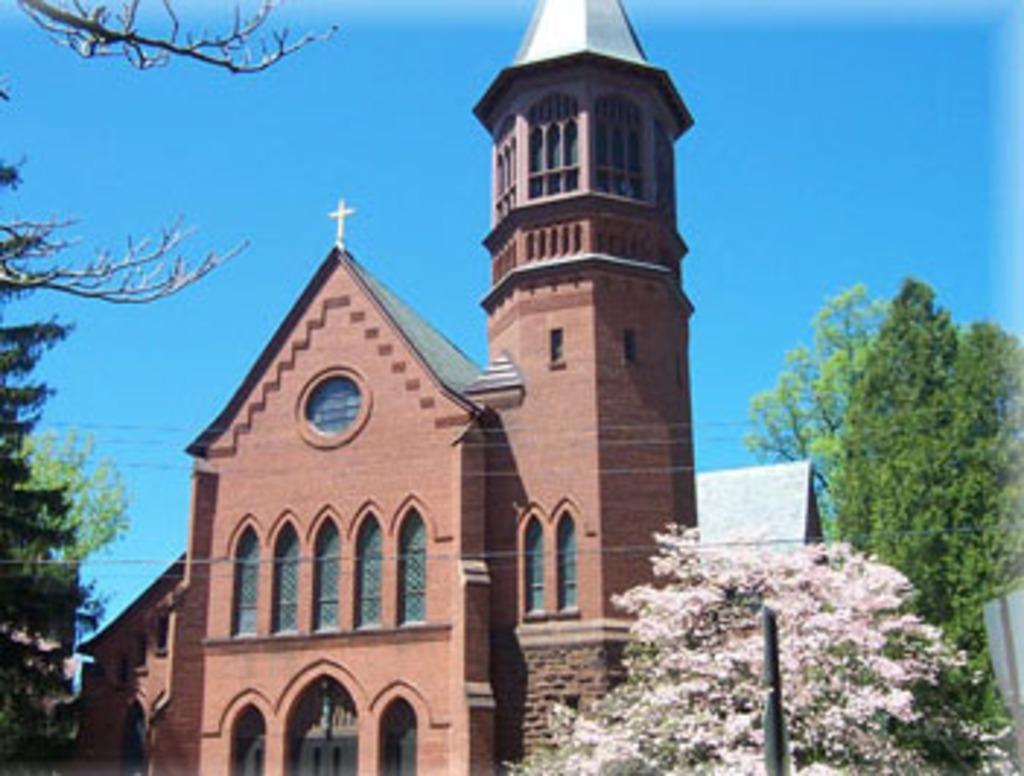Could you give a brief overview of what you see in this image? In this picture I can see the church. On the right and left I can see many trees. At the top I can see the sky. 